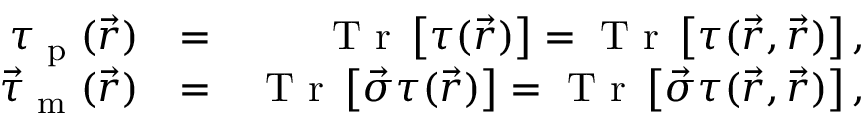Convert formula to latex. <formula><loc_0><loc_0><loc_500><loc_500>\begin{array} { r l r } { \tau _ { p } ( \vec { r } ) } & { = } & { T r \left [ \tau ( \vec { r } ) \right ] = T r \left [ \tau ( \vec { r } , \vec { r } ) \right ] , } \\ { \vec { \tau } _ { m } ( \vec { r } ) } & { = } & { T r \left [ \vec { \sigma } \tau ( \vec { r } ) \right ] = T r \left [ \vec { \sigma } \tau ( \vec { r } , \vec { r } ) \right ] , } \end{array}</formula> 